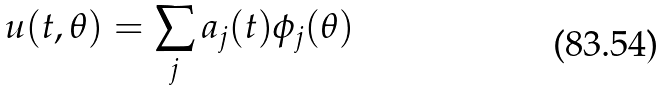<formula> <loc_0><loc_0><loc_500><loc_500>u ( t , \theta ) = \sum _ { j } a _ { j } ( t ) \phi _ { j } ( \theta )</formula> 